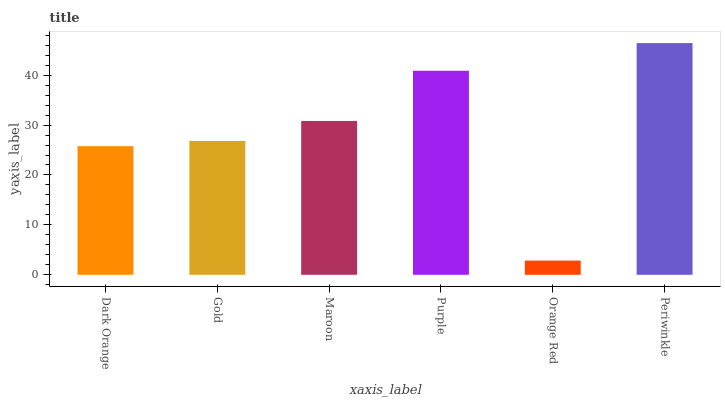Is Gold the minimum?
Answer yes or no. No. Is Gold the maximum?
Answer yes or no. No. Is Gold greater than Dark Orange?
Answer yes or no. Yes. Is Dark Orange less than Gold?
Answer yes or no. Yes. Is Dark Orange greater than Gold?
Answer yes or no. No. Is Gold less than Dark Orange?
Answer yes or no. No. Is Maroon the high median?
Answer yes or no. Yes. Is Gold the low median?
Answer yes or no. Yes. Is Dark Orange the high median?
Answer yes or no. No. Is Maroon the low median?
Answer yes or no. No. 